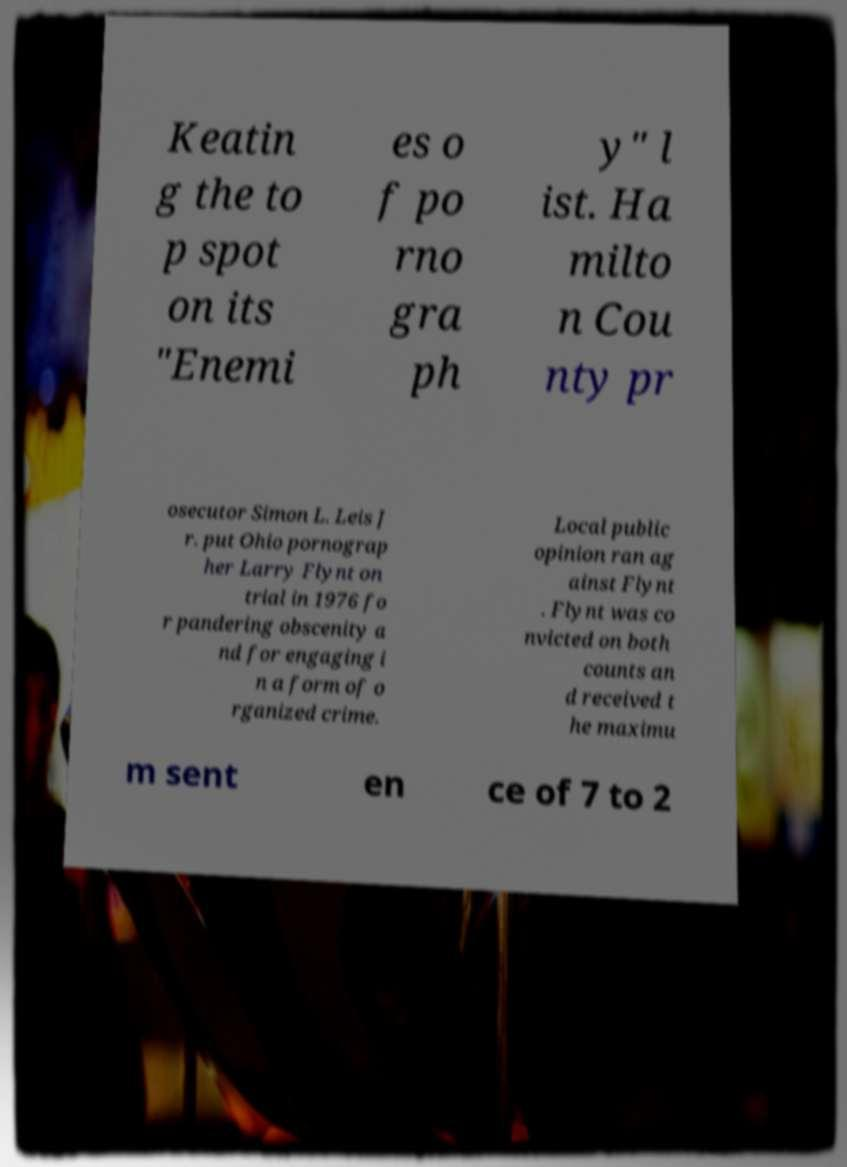Can you accurately transcribe the text from the provided image for me? Keatin g the to p spot on its "Enemi es o f po rno gra ph y" l ist. Ha milto n Cou nty pr osecutor Simon L. Leis J r. put Ohio pornograp her Larry Flynt on trial in 1976 fo r pandering obscenity a nd for engaging i n a form of o rganized crime. Local public opinion ran ag ainst Flynt . Flynt was co nvicted on both counts an d received t he maximu m sent en ce of 7 to 2 